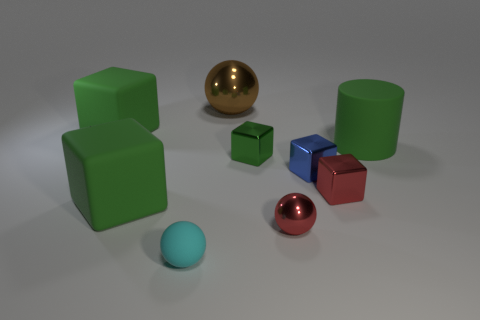There is a rubber thing that is to the right of the metal block that is to the right of the blue metal thing; what color is it?
Your answer should be compact. Green. There is a cube that is right of the large shiny object and left of the small blue metal thing; what size is it?
Keep it short and to the point. Small. Are there any other things that have the same color as the cylinder?
Your answer should be very brief. Yes. The brown thing that is the same material as the tiny blue cube is what shape?
Offer a terse response. Sphere. Do the green metal thing and the green object in front of the green metallic cube have the same shape?
Your response must be concise. Yes. There is a tiny blue thing that is to the right of the tiny red ball to the right of the small cyan rubber sphere; what is its material?
Provide a succinct answer. Metal. Is the number of large rubber cylinders that are on the left side of the big brown ball the same as the number of small blue shiny spheres?
Make the answer very short. Yes. Does the small object that is behind the tiny blue block have the same color as the big rubber block that is in front of the big cylinder?
Provide a short and direct response. Yes. What number of things are behind the green metal thing and to the right of the tiny blue metal block?
Make the answer very short. 1. What number of other objects are the same shape as the blue shiny object?
Your response must be concise. 4. 